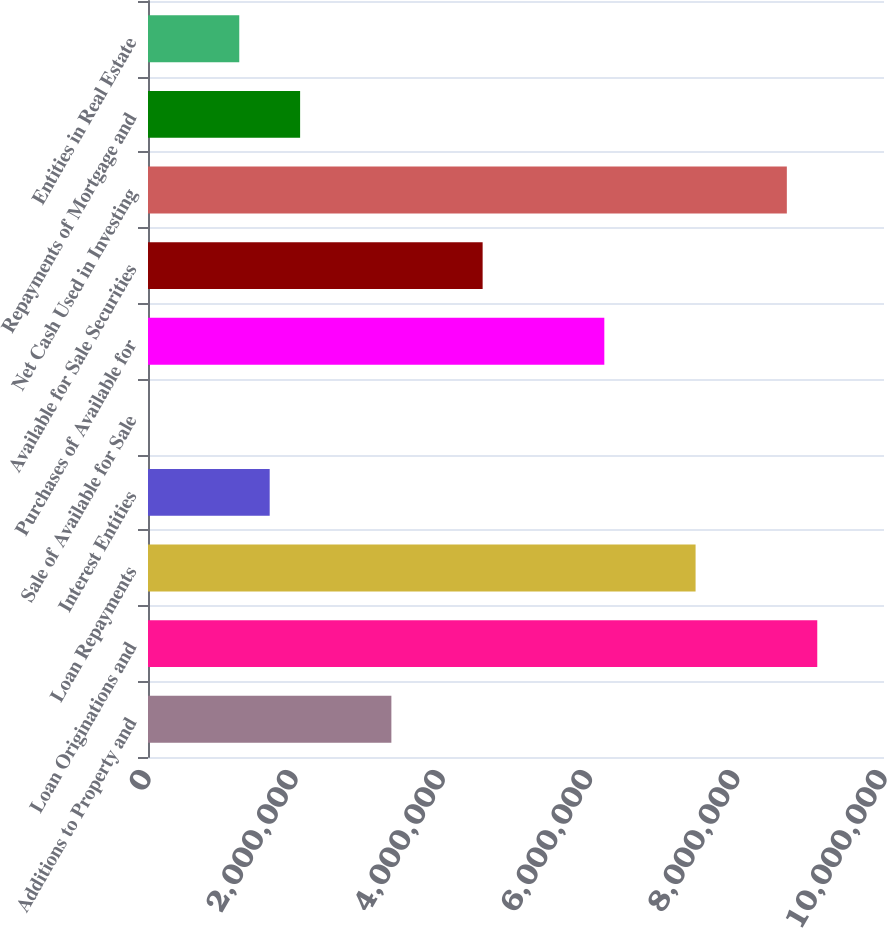<chart> <loc_0><loc_0><loc_500><loc_500><bar_chart><fcel>Additions to Property and<fcel>Loan Originations and<fcel>Loan Repayments<fcel>Interest Entities<fcel>Sale of Available for Sale<fcel>Purchases of Available for<fcel>Available for Sale Securities<fcel>Net Cash Used in Investing<fcel>Repayments of Mortgage and<fcel>Entities in Real Estate<nl><fcel>3.30669e+06<fcel>9.09326e+06<fcel>7.43996e+06<fcel>1.65339e+06<fcel>81<fcel>6.19998e+06<fcel>4.54667e+06<fcel>8.67994e+06<fcel>2.06671e+06<fcel>1.24006e+06<nl></chart> 